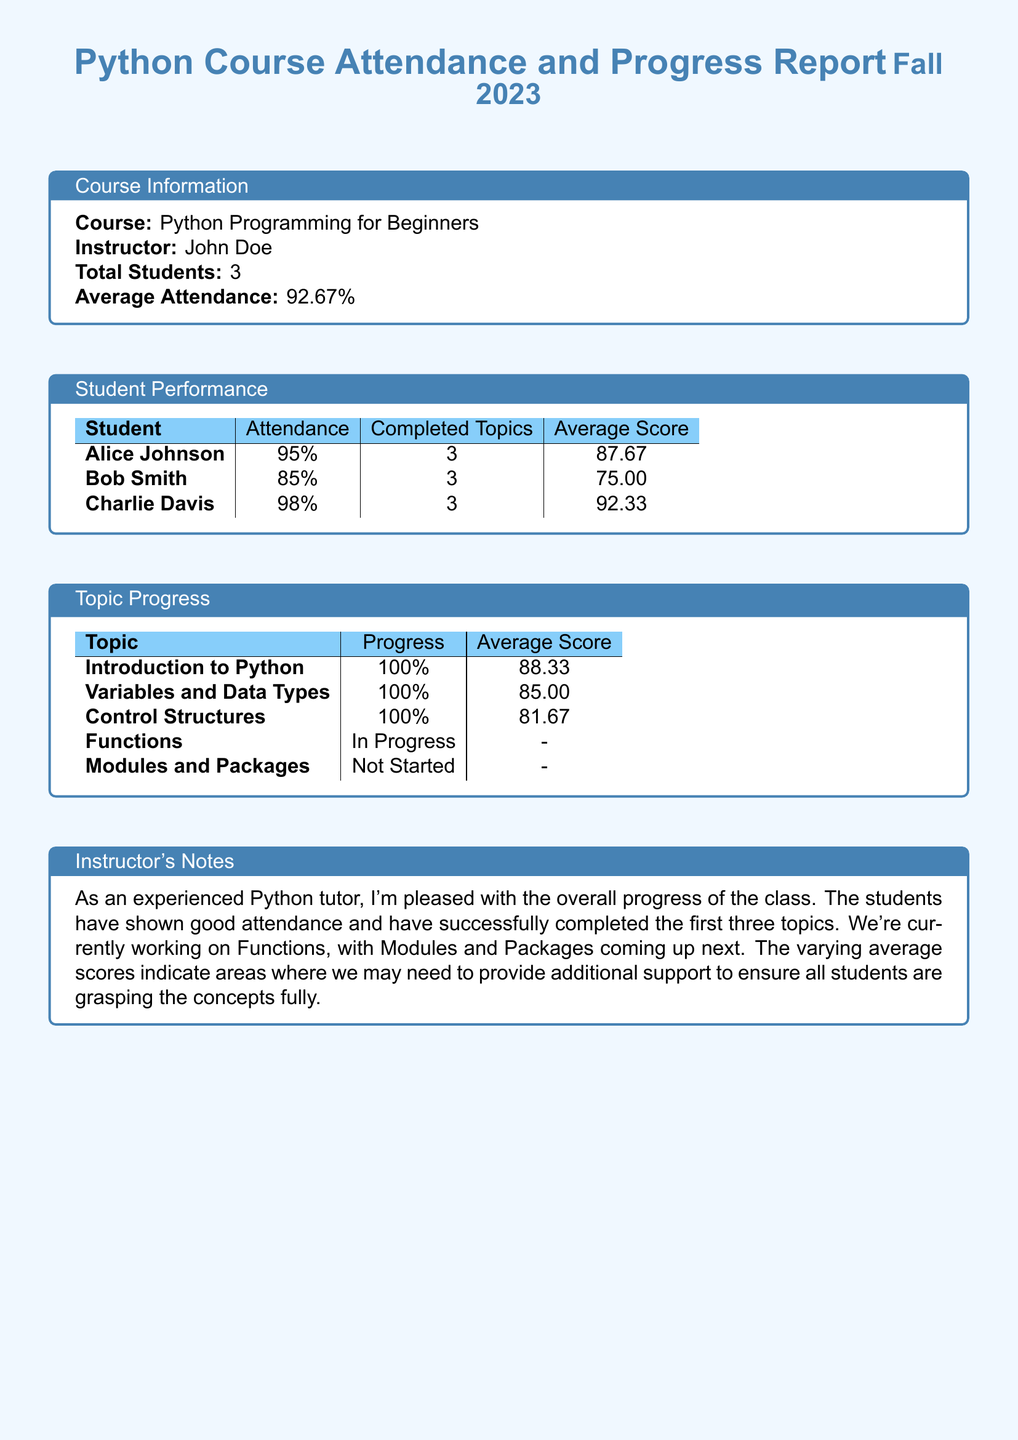What is the course name? The course name is stated in the document as part of the course information section.
Answer: Python Programming for Beginners Who is the instructor? The instructor's name is provided in the course information section of the document.
Answer: John Doe How many students are in the course? The total number of students enrolled is indicated in the course information section.
Answer: 3 What is the average attendance percentage? The average attendance percentage is outlined in the document under course information.
Answer: 92.67% Which student has the highest average score? To determine this, we compare the average scores in the student performance table.
Answer: Charlie Davis What is the progress percentage for Control Structures? The progress percentage for Control Structures is included in the topic progress table.
Answer: 100% How many topics have been completed by all students? This is found in the student performance table, where the completed topics for each student are tallied.
Answer: 3 What topic is currently in progress? The topic currently in progress is specified in the topic progress section.
Answer: Functions What is the average score for the Variables and Data Types topic? This information is directly pulled from the topic progress table detailing average scores.
Answer: 85.00 What are the upcoming topics after Functions? The document mentions the upcoming topic after Functions in the instructor's notes section.
Answer: Modules and Packages 